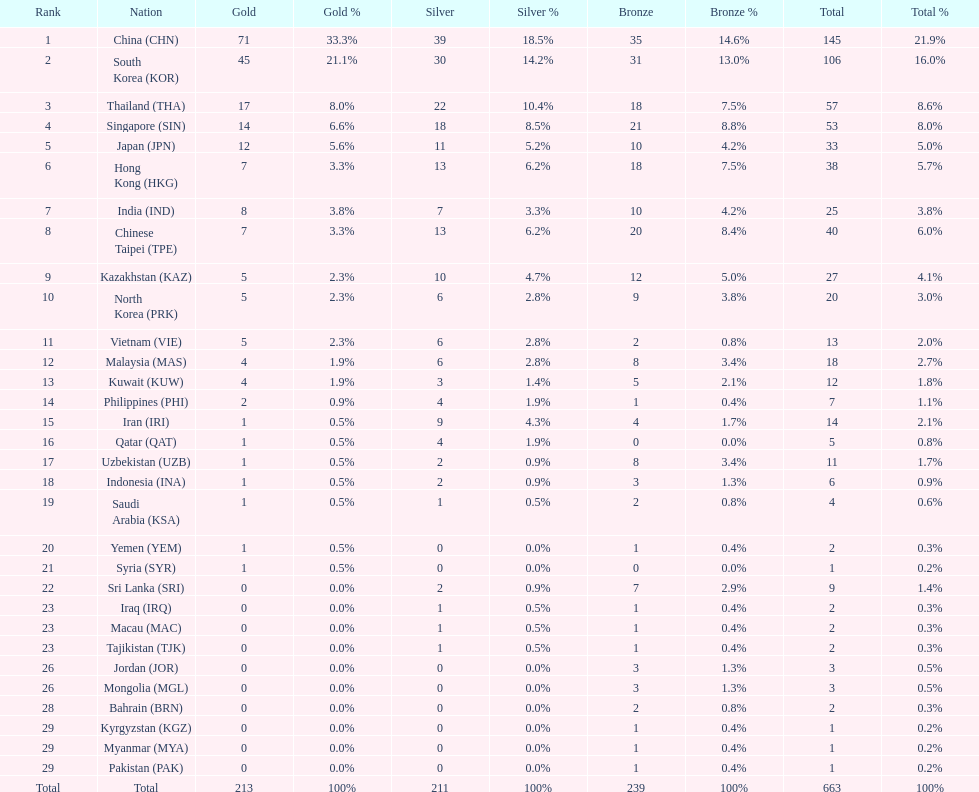Which nation has more gold medals, kuwait or india? India (IND). 